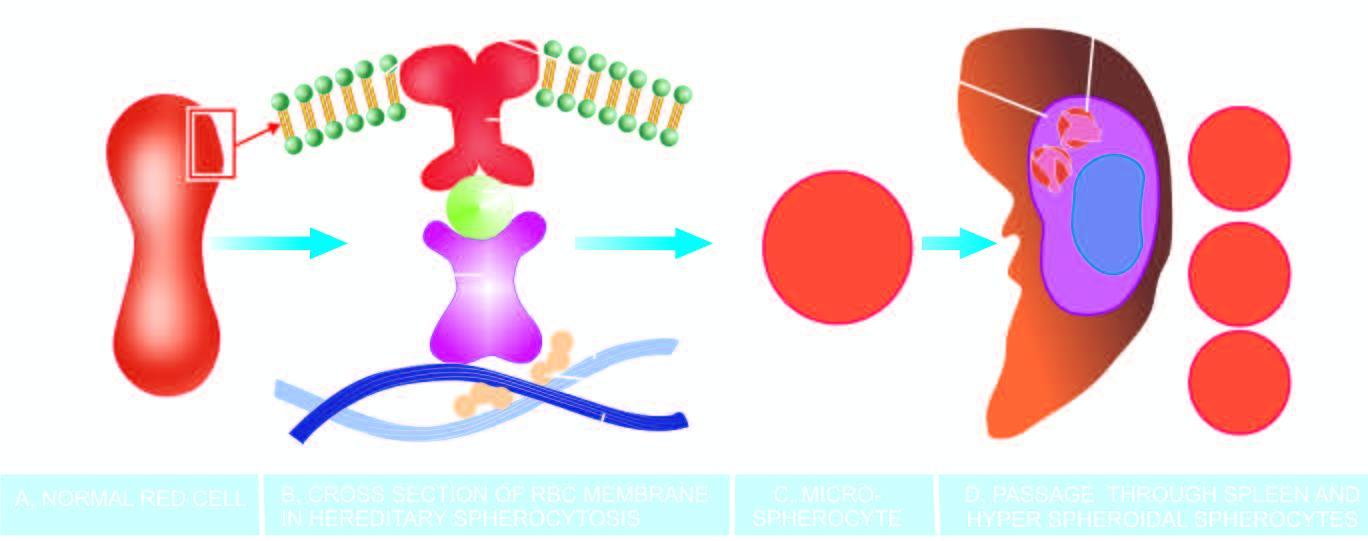do these rigid spherical cells lose their cell membrane further during passage through the spleen?
Answer the question using a single word or phrase. Yes 